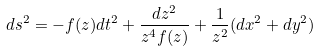Convert formula to latex. <formula><loc_0><loc_0><loc_500><loc_500>d s ^ { 2 } = - f ( z ) d t ^ { 2 } + \frac { d z ^ { 2 } } { z ^ { 4 } f ( z ) } + \frac { 1 } { z ^ { 2 } } ( d x ^ { 2 } + d y ^ { 2 } )</formula> 